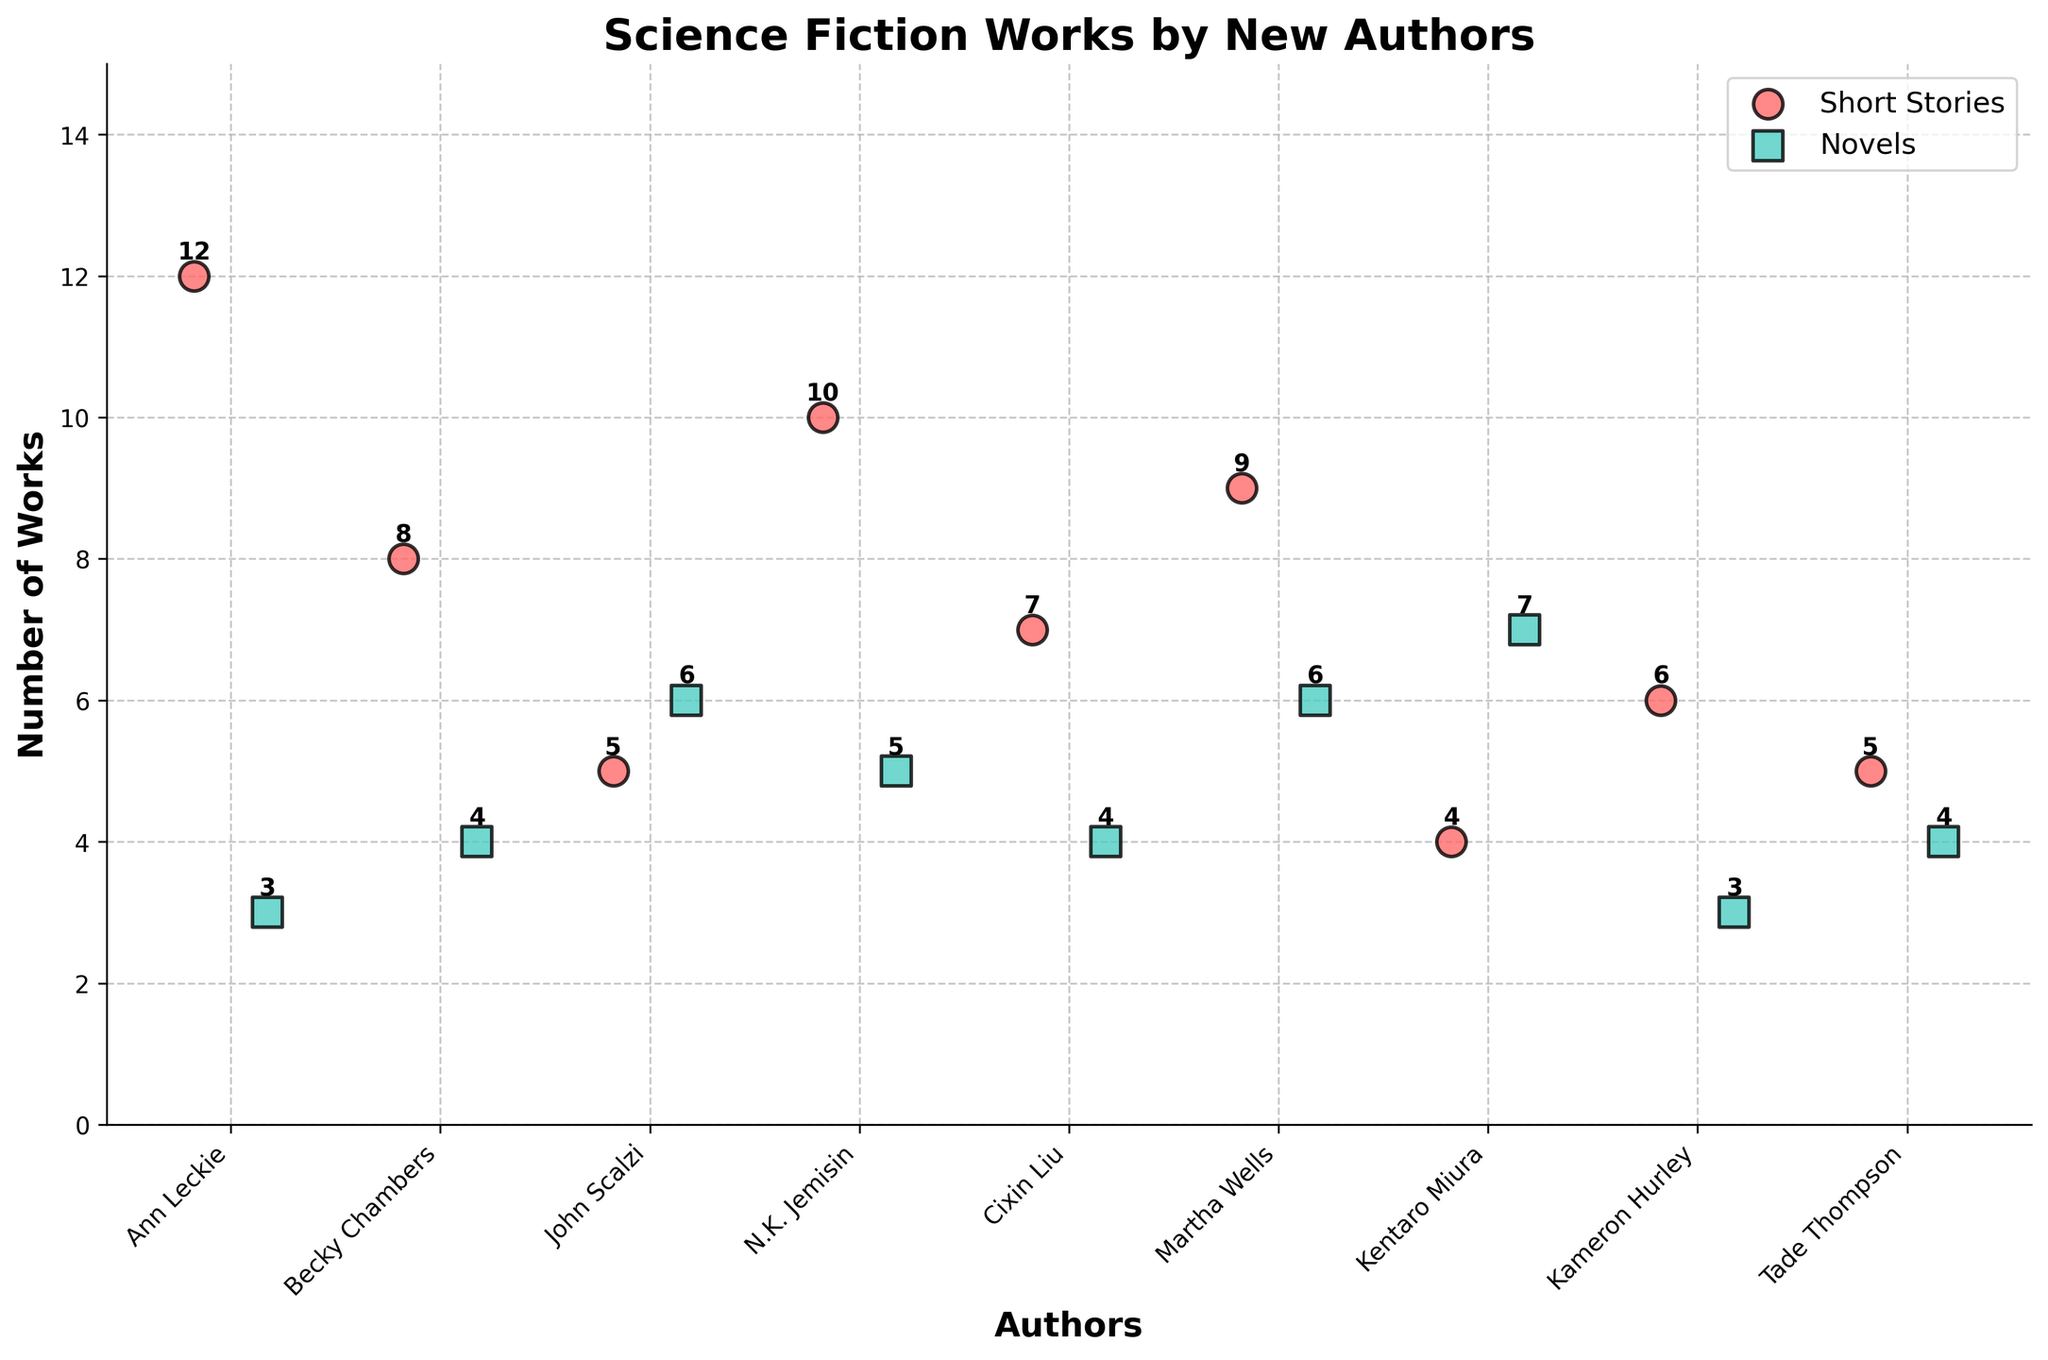What's the title of this figure? The title of the figure is displayed above the chart.
Answer: Science Fiction Works by New Authors Which author has published the most short stories? By examining the heights of the scatter points for short stories, the tallest one represents the author with the most short stories.
Answer: Ann Leckie How many authors published more novels than short stories? Compare the height of each author's scatter points for short stories and novels. John Scalzi and Kentaro Miura have taller points for novels.
Answer: 2 What's the total number of short stories published by all authors? Sum the number of short stories for all authors. 12 + 8 + 5 + 10 + 7 + 9 + 4 + 6 + 5 = 66
Answer: 66 Who published an equal number of short stories and novels? Look for authors with scatter points at the same height for both short stories and novels.
Answer: None What's the difference in the number of novels published by Martha Wells and Becky Chambers? Subtract the number of novels by Becky Chambers from Martha Wells: 6 - 4 = 2
Answer: 2 Which author published the least amount of short stories? Identify the shortest scatter point for short stories.
Answer: Kentaro Miura Which author has the highest total number of works (short stories + novels)? Add the number of short stories and novels for each author to find the maximum. Ann Leckie: 12 + 3 = 15
Answer: Ann Leckie What's the average number of short stories published by the authors? Compute the mean by dividing the total number of short stories published by the number of authors: 66 / 9 ≈ 7.33
Answer: 7.33 Which author's total number of published works is exactly 9? Add the number of short stories and novels for each author and identify those with a total of 9. Becky Chambers: 8 + 4 ≠ 9, John Scalzi: 5 + 6 ≠ 9, N.K. Jemisin: 10 + 5 ≠ 9, Cixin Liu: 7 + 4 ≠ 9, Martha Wells: 9 + 6 = 15 ≠ 9, Kentaro Miura: 4 + 7 = 11 ≠ 9, Kameron Hurley: 6 + 3 = 9.
Answer: Kameron Hurley 